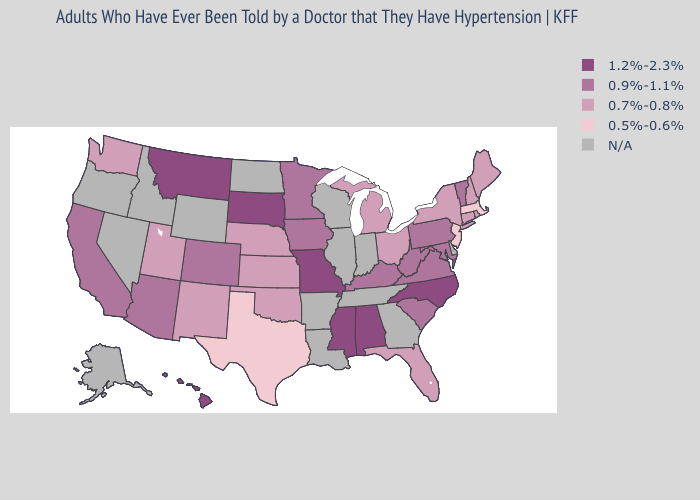What is the lowest value in the South?
Be succinct. 0.5%-0.6%. What is the lowest value in states that border Montana?
Keep it brief. 1.2%-2.3%. Which states have the lowest value in the USA?
Be succinct. Massachusetts, New Jersey, Texas. What is the lowest value in the USA?
Give a very brief answer. 0.5%-0.6%. What is the value of Wyoming?
Keep it brief. N/A. Name the states that have a value in the range 0.5%-0.6%?
Write a very short answer. Massachusetts, New Jersey, Texas. Does Maine have the lowest value in the USA?
Write a very short answer. No. Name the states that have a value in the range 1.2%-2.3%?
Be succinct. Alabama, Hawaii, Mississippi, Missouri, Montana, North Carolina, South Dakota. Name the states that have a value in the range 1.2%-2.3%?
Short answer required. Alabama, Hawaii, Mississippi, Missouri, Montana, North Carolina, South Dakota. Does the map have missing data?
Answer briefly. Yes. Name the states that have a value in the range N/A?
Be succinct. Alaska, Arkansas, Delaware, Georgia, Idaho, Illinois, Indiana, Louisiana, Nevada, North Dakota, Oregon, Tennessee, Wisconsin, Wyoming. Which states have the lowest value in the MidWest?
Answer briefly. Kansas, Michigan, Nebraska, Ohio. What is the highest value in the USA?
Short answer required. 1.2%-2.3%. Among the states that border Missouri , which have the highest value?
Be succinct. Iowa, Kentucky. 